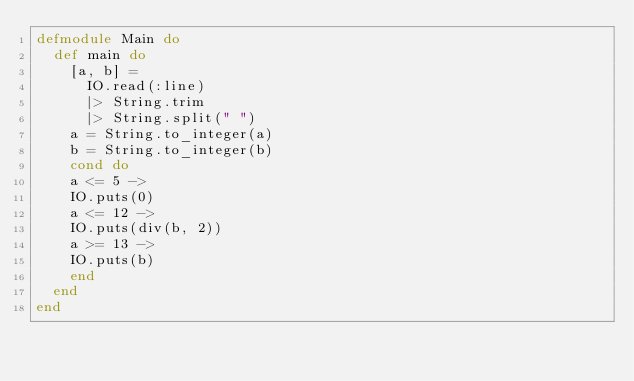Convert code to text. <code><loc_0><loc_0><loc_500><loc_500><_Elixir_>defmodule Main do
  def main do
    [a, b] =
      IO.read(:line)
      |> String.trim
      |> String.split(" ")
    a = String.to_integer(a)
    b = String.to_integer(b)
    cond do
    a <= 5 -> 
    IO.puts(0) 
    a <= 12 ->
    IO.puts(div(b, 2))
    a >= 13 ->
    IO.puts(b)
    end
  end
end
</code> 